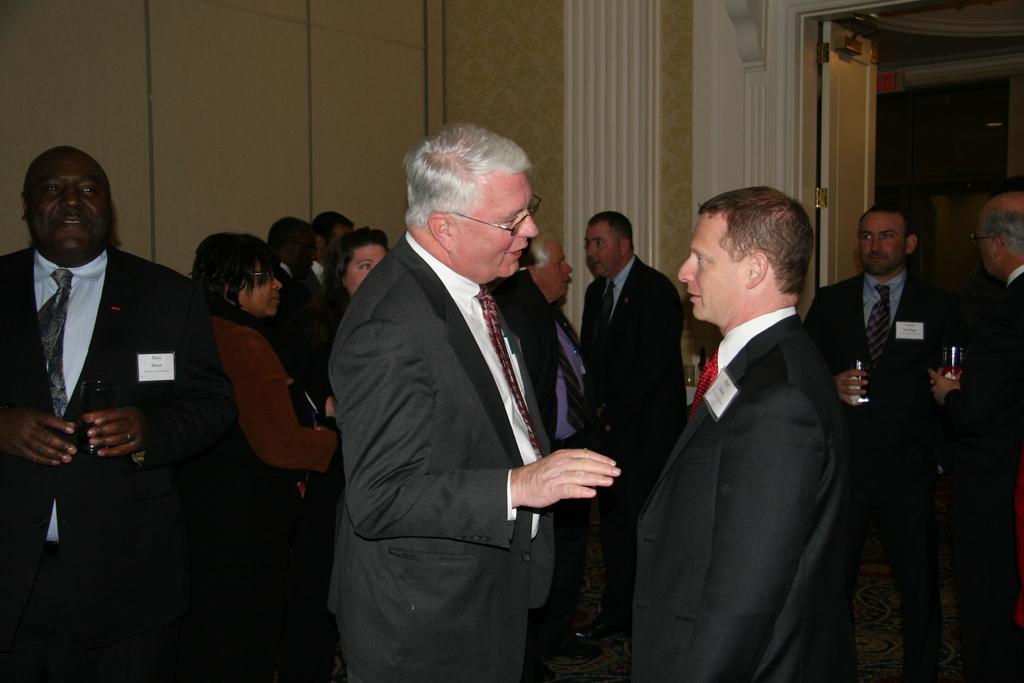How would you summarize this image in a sentence or two? In this image in front there are people. Behind them there is a wall. On the right side of the image there is a door. 